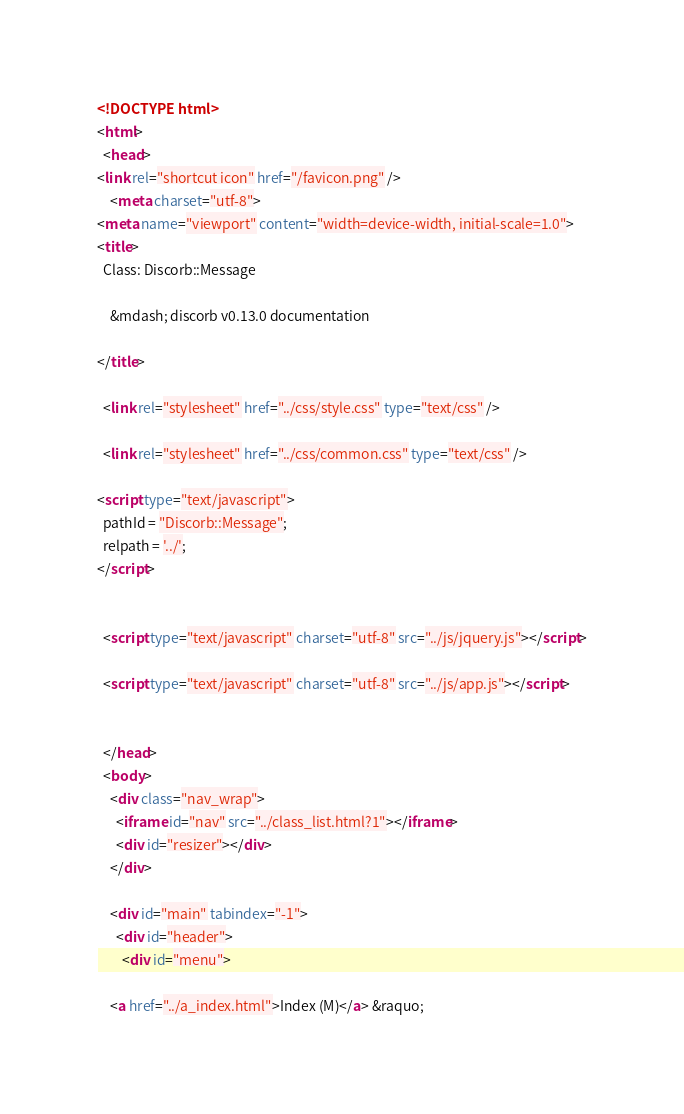<code> <loc_0><loc_0><loc_500><loc_500><_HTML_><!DOCTYPE html>
<html>
  <head>
<link rel="shortcut icon" href="/favicon.png" />
    <meta charset="utf-8">
<meta name="viewport" content="width=device-width, initial-scale=1.0">
<title>
  Class: Discorb::Message
  
    &mdash; discorb v0.13.0 documentation
  
</title>

  <link rel="stylesheet" href="../css/style.css" type="text/css" />

  <link rel="stylesheet" href="../css/common.css" type="text/css" />

<script type="text/javascript">
  pathId = "Discorb::Message";
  relpath = '../';
</script>


  <script type="text/javascript" charset="utf-8" src="../js/jquery.js"></script>

  <script type="text/javascript" charset="utf-8" src="../js/app.js"></script>


  </head>
  <body>
    <div class="nav_wrap">
      <iframe id="nav" src="../class_list.html?1"></iframe>
      <div id="resizer"></div>
    </div>

    <div id="main" tabindex="-1">
      <div id="header">
        <div id="menu">
  
    <a href="../a_index.html">Index (M)</a> &raquo;</code> 